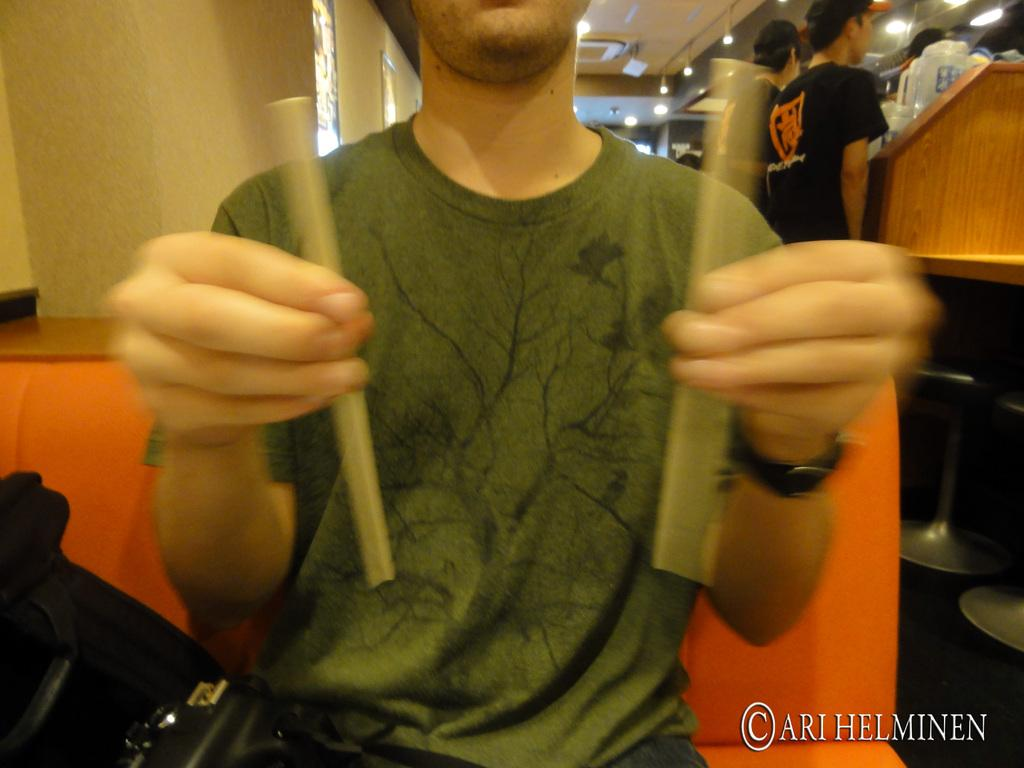What is the person in the image holding? The person is holding 2 sticks in the image. Can you describe the other people visible in the image? There are other people visible in the image, but their actions or features are not specified. What is located at the top of the image? There are lights at the top of the image. How long does it take for the worm to crawl across the image? There is no worm present in the image, so it is not possible to determine how long it would take for a worm to crawl across the image. 